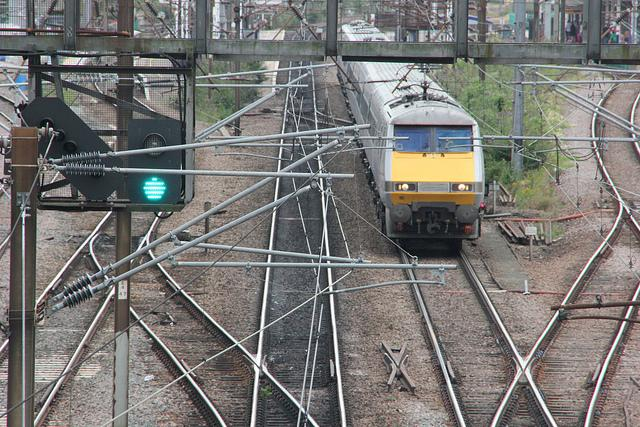The rightmost set of rails leads to which railway structure? Please explain your reasoning. train station. All trains need to end up at a train station. 